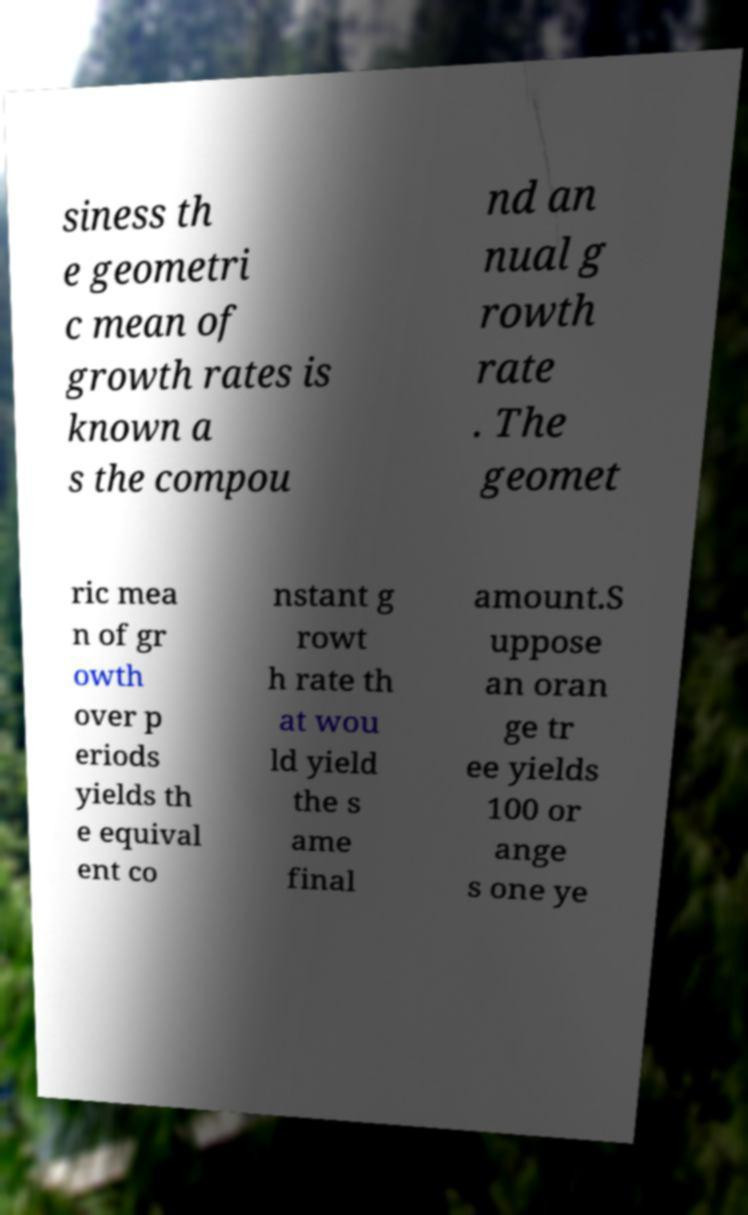Please read and relay the text visible in this image. What does it say? siness th e geometri c mean of growth rates is known a s the compou nd an nual g rowth rate . The geomet ric mea n of gr owth over p eriods yields th e equival ent co nstant g rowt h rate th at wou ld yield the s ame final amount.S uppose an oran ge tr ee yields 100 or ange s one ye 